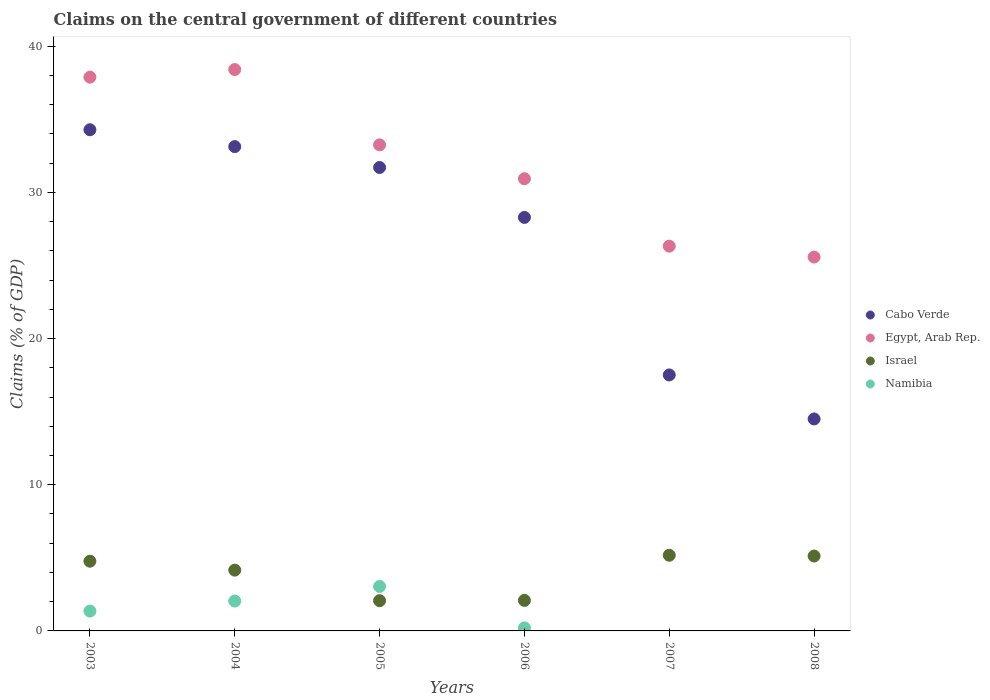Is the number of dotlines equal to the number of legend labels?
Give a very brief answer. No. What is the percentage of GDP claimed on the central government in Israel in 2005?
Ensure brevity in your answer.  2.07. Across all years, what is the maximum percentage of GDP claimed on the central government in Israel?
Your response must be concise. 5.18. What is the total percentage of GDP claimed on the central government in Namibia in the graph?
Ensure brevity in your answer.  6.65. What is the difference between the percentage of GDP claimed on the central government in Cabo Verde in 2006 and that in 2007?
Your response must be concise. 10.77. What is the difference between the percentage of GDP claimed on the central government in Egypt, Arab Rep. in 2006 and the percentage of GDP claimed on the central government in Namibia in 2003?
Offer a terse response. 29.57. What is the average percentage of GDP claimed on the central government in Egypt, Arab Rep. per year?
Provide a short and direct response. 32.06. In the year 2004, what is the difference between the percentage of GDP claimed on the central government in Cabo Verde and percentage of GDP claimed on the central government in Egypt, Arab Rep.?
Your answer should be very brief. -5.27. In how many years, is the percentage of GDP claimed on the central government in Namibia greater than 36 %?
Your answer should be compact. 0. What is the ratio of the percentage of GDP claimed on the central government in Namibia in 2005 to that in 2006?
Your answer should be compact. 14.51. Is the percentage of GDP claimed on the central government in Israel in 2005 less than that in 2006?
Provide a succinct answer. Yes. What is the difference between the highest and the second highest percentage of GDP claimed on the central government in Namibia?
Make the answer very short. 1. What is the difference between the highest and the lowest percentage of GDP claimed on the central government in Namibia?
Keep it short and to the point. 3.04. Is the sum of the percentage of GDP claimed on the central government in Egypt, Arab Rep. in 2003 and 2004 greater than the maximum percentage of GDP claimed on the central government in Namibia across all years?
Your answer should be very brief. Yes. Is the percentage of GDP claimed on the central government in Cabo Verde strictly greater than the percentage of GDP claimed on the central government in Namibia over the years?
Provide a short and direct response. Yes. Is the percentage of GDP claimed on the central government in Israel strictly less than the percentage of GDP claimed on the central government in Cabo Verde over the years?
Your answer should be compact. Yes. How many dotlines are there?
Offer a very short reply. 4. How many years are there in the graph?
Your answer should be compact. 6. Are the values on the major ticks of Y-axis written in scientific E-notation?
Ensure brevity in your answer.  No. Does the graph contain any zero values?
Give a very brief answer. Yes. How many legend labels are there?
Ensure brevity in your answer.  4. What is the title of the graph?
Your answer should be very brief. Claims on the central government of different countries. What is the label or title of the Y-axis?
Make the answer very short. Claims (% of GDP). What is the Claims (% of GDP) of Cabo Verde in 2003?
Provide a succinct answer. 34.28. What is the Claims (% of GDP) of Egypt, Arab Rep. in 2003?
Your answer should be very brief. 37.88. What is the Claims (% of GDP) of Israel in 2003?
Your answer should be compact. 4.77. What is the Claims (% of GDP) of Namibia in 2003?
Provide a succinct answer. 1.36. What is the Claims (% of GDP) in Cabo Verde in 2004?
Your answer should be compact. 33.13. What is the Claims (% of GDP) in Egypt, Arab Rep. in 2004?
Ensure brevity in your answer.  38.4. What is the Claims (% of GDP) in Israel in 2004?
Make the answer very short. 4.16. What is the Claims (% of GDP) of Namibia in 2004?
Give a very brief answer. 2.04. What is the Claims (% of GDP) of Cabo Verde in 2005?
Give a very brief answer. 31.7. What is the Claims (% of GDP) of Egypt, Arab Rep. in 2005?
Offer a very short reply. 33.25. What is the Claims (% of GDP) of Israel in 2005?
Provide a succinct answer. 2.07. What is the Claims (% of GDP) in Namibia in 2005?
Keep it short and to the point. 3.04. What is the Claims (% of GDP) of Cabo Verde in 2006?
Provide a succinct answer. 28.29. What is the Claims (% of GDP) in Egypt, Arab Rep. in 2006?
Provide a short and direct response. 30.93. What is the Claims (% of GDP) in Israel in 2006?
Ensure brevity in your answer.  2.09. What is the Claims (% of GDP) of Namibia in 2006?
Your response must be concise. 0.21. What is the Claims (% of GDP) in Cabo Verde in 2007?
Offer a terse response. 17.51. What is the Claims (% of GDP) in Egypt, Arab Rep. in 2007?
Your response must be concise. 26.32. What is the Claims (% of GDP) in Israel in 2007?
Ensure brevity in your answer.  5.18. What is the Claims (% of GDP) in Namibia in 2007?
Give a very brief answer. 0. What is the Claims (% of GDP) in Cabo Verde in 2008?
Your response must be concise. 14.5. What is the Claims (% of GDP) in Egypt, Arab Rep. in 2008?
Make the answer very short. 25.57. What is the Claims (% of GDP) of Israel in 2008?
Provide a short and direct response. 5.12. What is the Claims (% of GDP) of Namibia in 2008?
Provide a succinct answer. 0. Across all years, what is the maximum Claims (% of GDP) of Cabo Verde?
Your answer should be very brief. 34.28. Across all years, what is the maximum Claims (% of GDP) in Egypt, Arab Rep.?
Keep it short and to the point. 38.4. Across all years, what is the maximum Claims (% of GDP) of Israel?
Keep it short and to the point. 5.18. Across all years, what is the maximum Claims (% of GDP) of Namibia?
Provide a succinct answer. 3.04. Across all years, what is the minimum Claims (% of GDP) of Cabo Verde?
Offer a terse response. 14.5. Across all years, what is the minimum Claims (% of GDP) in Egypt, Arab Rep.?
Offer a terse response. 25.57. Across all years, what is the minimum Claims (% of GDP) of Israel?
Provide a succinct answer. 2.07. Across all years, what is the minimum Claims (% of GDP) of Namibia?
Keep it short and to the point. 0. What is the total Claims (% of GDP) of Cabo Verde in the graph?
Make the answer very short. 159.4. What is the total Claims (% of GDP) of Egypt, Arab Rep. in the graph?
Your response must be concise. 192.35. What is the total Claims (% of GDP) of Israel in the graph?
Give a very brief answer. 23.38. What is the total Claims (% of GDP) of Namibia in the graph?
Your answer should be very brief. 6.65. What is the difference between the Claims (% of GDP) of Cabo Verde in 2003 and that in 2004?
Offer a very short reply. 1.15. What is the difference between the Claims (% of GDP) in Egypt, Arab Rep. in 2003 and that in 2004?
Give a very brief answer. -0.52. What is the difference between the Claims (% of GDP) in Israel in 2003 and that in 2004?
Provide a short and direct response. 0.61. What is the difference between the Claims (% of GDP) of Namibia in 2003 and that in 2004?
Make the answer very short. -0.68. What is the difference between the Claims (% of GDP) in Cabo Verde in 2003 and that in 2005?
Your response must be concise. 2.58. What is the difference between the Claims (% of GDP) in Egypt, Arab Rep. in 2003 and that in 2005?
Offer a very short reply. 4.63. What is the difference between the Claims (% of GDP) of Israel in 2003 and that in 2005?
Your answer should be very brief. 2.7. What is the difference between the Claims (% of GDP) of Namibia in 2003 and that in 2005?
Give a very brief answer. -1.69. What is the difference between the Claims (% of GDP) in Cabo Verde in 2003 and that in 2006?
Ensure brevity in your answer.  6. What is the difference between the Claims (% of GDP) of Egypt, Arab Rep. in 2003 and that in 2006?
Your answer should be very brief. 6.95. What is the difference between the Claims (% of GDP) of Israel in 2003 and that in 2006?
Give a very brief answer. 2.68. What is the difference between the Claims (% of GDP) in Namibia in 2003 and that in 2006?
Your answer should be compact. 1.15. What is the difference between the Claims (% of GDP) in Cabo Verde in 2003 and that in 2007?
Your answer should be compact. 16.77. What is the difference between the Claims (% of GDP) of Egypt, Arab Rep. in 2003 and that in 2007?
Provide a short and direct response. 11.56. What is the difference between the Claims (% of GDP) of Israel in 2003 and that in 2007?
Your answer should be compact. -0.41. What is the difference between the Claims (% of GDP) of Cabo Verde in 2003 and that in 2008?
Your response must be concise. 19.78. What is the difference between the Claims (% of GDP) in Egypt, Arab Rep. in 2003 and that in 2008?
Provide a short and direct response. 12.31. What is the difference between the Claims (% of GDP) in Israel in 2003 and that in 2008?
Make the answer very short. -0.35. What is the difference between the Claims (% of GDP) of Cabo Verde in 2004 and that in 2005?
Make the answer very short. 1.43. What is the difference between the Claims (% of GDP) of Egypt, Arab Rep. in 2004 and that in 2005?
Your answer should be compact. 5.15. What is the difference between the Claims (% of GDP) of Israel in 2004 and that in 2005?
Provide a short and direct response. 2.09. What is the difference between the Claims (% of GDP) of Namibia in 2004 and that in 2005?
Make the answer very short. -1. What is the difference between the Claims (% of GDP) of Cabo Verde in 2004 and that in 2006?
Make the answer very short. 4.84. What is the difference between the Claims (% of GDP) of Egypt, Arab Rep. in 2004 and that in 2006?
Your answer should be compact. 7.47. What is the difference between the Claims (% of GDP) of Israel in 2004 and that in 2006?
Keep it short and to the point. 2.07. What is the difference between the Claims (% of GDP) of Namibia in 2004 and that in 2006?
Offer a terse response. 1.83. What is the difference between the Claims (% of GDP) in Cabo Verde in 2004 and that in 2007?
Offer a terse response. 15.62. What is the difference between the Claims (% of GDP) of Egypt, Arab Rep. in 2004 and that in 2007?
Your answer should be very brief. 12.08. What is the difference between the Claims (% of GDP) in Israel in 2004 and that in 2007?
Offer a very short reply. -1.02. What is the difference between the Claims (% of GDP) of Cabo Verde in 2004 and that in 2008?
Keep it short and to the point. 18.63. What is the difference between the Claims (% of GDP) of Egypt, Arab Rep. in 2004 and that in 2008?
Your answer should be compact. 12.83. What is the difference between the Claims (% of GDP) in Israel in 2004 and that in 2008?
Your answer should be compact. -0.96. What is the difference between the Claims (% of GDP) in Cabo Verde in 2005 and that in 2006?
Offer a terse response. 3.42. What is the difference between the Claims (% of GDP) of Egypt, Arab Rep. in 2005 and that in 2006?
Provide a short and direct response. 2.32. What is the difference between the Claims (% of GDP) in Israel in 2005 and that in 2006?
Offer a very short reply. -0.02. What is the difference between the Claims (% of GDP) in Namibia in 2005 and that in 2006?
Make the answer very short. 2.83. What is the difference between the Claims (% of GDP) of Cabo Verde in 2005 and that in 2007?
Offer a terse response. 14.19. What is the difference between the Claims (% of GDP) in Egypt, Arab Rep. in 2005 and that in 2007?
Offer a very short reply. 6.93. What is the difference between the Claims (% of GDP) in Israel in 2005 and that in 2007?
Offer a very short reply. -3.11. What is the difference between the Claims (% of GDP) in Cabo Verde in 2005 and that in 2008?
Your response must be concise. 17.2. What is the difference between the Claims (% of GDP) of Egypt, Arab Rep. in 2005 and that in 2008?
Provide a succinct answer. 7.67. What is the difference between the Claims (% of GDP) in Israel in 2005 and that in 2008?
Your response must be concise. -3.05. What is the difference between the Claims (% of GDP) in Cabo Verde in 2006 and that in 2007?
Offer a terse response. 10.77. What is the difference between the Claims (% of GDP) in Egypt, Arab Rep. in 2006 and that in 2007?
Give a very brief answer. 4.61. What is the difference between the Claims (% of GDP) in Israel in 2006 and that in 2007?
Make the answer very short. -3.09. What is the difference between the Claims (% of GDP) of Cabo Verde in 2006 and that in 2008?
Your answer should be compact. 13.79. What is the difference between the Claims (% of GDP) in Egypt, Arab Rep. in 2006 and that in 2008?
Ensure brevity in your answer.  5.36. What is the difference between the Claims (% of GDP) of Israel in 2006 and that in 2008?
Provide a succinct answer. -3.03. What is the difference between the Claims (% of GDP) of Cabo Verde in 2007 and that in 2008?
Your answer should be compact. 3.01. What is the difference between the Claims (% of GDP) in Egypt, Arab Rep. in 2007 and that in 2008?
Provide a succinct answer. 0.75. What is the difference between the Claims (% of GDP) of Israel in 2007 and that in 2008?
Give a very brief answer. 0.05. What is the difference between the Claims (% of GDP) in Cabo Verde in 2003 and the Claims (% of GDP) in Egypt, Arab Rep. in 2004?
Offer a terse response. -4.12. What is the difference between the Claims (% of GDP) of Cabo Verde in 2003 and the Claims (% of GDP) of Israel in 2004?
Give a very brief answer. 30.12. What is the difference between the Claims (% of GDP) in Cabo Verde in 2003 and the Claims (% of GDP) in Namibia in 2004?
Keep it short and to the point. 32.24. What is the difference between the Claims (% of GDP) in Egypt, Arab Rep. in 2003 and the Claims (% of GDP) in Israel in 2004?
Ensure brevity in your answer.  33.72. What is the difference between the Claims (% of GDP) of Egypt, Arab Rep. in 2003 and the Claims (% of GDP) of Namibia in 2004?
Your answer should be very brief. 35.84. What is the difference between the Claims (% of GDP) of Israel in 2003 and the Claims (% of GDP) of Namibia in 2004?
Provide a short and direct response. 2.73. What is the difference between the Claims (% of GDP) in Cabo Verde in 2003 and the Claims (% of GDP) in Egypt, Arab Rep. in 2005?
Provide a short and direct response. 1.03. What is the difference between the Claims (% of GDP) of Cabo Verde in 2003 and the Claims (% of GDP) of Israel in 2005?
Ensure brevity in your answer.  32.21. What is the difference between the Claims (% of GDP) of Cabo Verde in 2003 and the Claims (% of GDP) of Namibia in 2005?
Your answer should be very brief. 31.24. What is the difference between the Claims (% of GDP) in Egypt, Arab Rep. in 2003 and the Claims (% of GDP) in Israel in 2005?
Your response must be concise. 35.81. What is the difference between the Claims (% of GDP) in Egypt, Arab Rep. in 2003 and the Claims (% of GDP) in Namibia in 2005?
Ensure brevity in your answer.  34.83. What is the difference between the Claims (% of GDP) in Israel in 2003 and the Claims (% of GDP) in Namibia in 2005?
Your answer should be compact. 1.73. What is the difference between the Claims (% of GDP) of Cabo Verde in 2003 and the Claims (% of GDP) of Egypt, Arab Rep. in 2006?
Your answer should be very brief. 3.35. What is the difference between the Claims (% of GDP) in Cabo Verde in 2003 and the Claims (% of GDP) in Israel in 2006?
Your answer should be compact. 32.19. What is the difference between the Claims (% of GDP) in Cabo Verde in 2003 and the Claims (% of GDP) in Namibia in 2006?
Make the answer very short. 34.07. What is the difference between the Claims (% of GDP) in Egypt, Arab Rep. in 2003 and the Claims (% of GDP) in Israel in 2006?
Your response must be concise. 35.79. What is the difference between the Claims (% of GDP) in Egypt, Arab Rep. in 2003 and the Claims (% of GDP) in Namibia in 2006?
Your answer should be compact. 37.67. What is the difference between the Claims (% of GDP) in Israel in 2003 and the Claims (% of GDP) in Namibia in 2006?
Keep it short and to the point. 4.56. What is the difference between the Claims (% of GDP) of Cabo Verde in 2003 and the Claims (% of GDP) of Egypt, Arab Rep. in 2007?
Keep it short and to the point. 7.96. What is the difference between the Claims (% of GDP) of Cabo Verde in 2003 and the Claims (% of GDP) of Israel in 2007?
Provide a short and direct response. 29.11. What is the difference between the Claims (% of GDP) of Egypt, Arab Rep. in 2003 and the Claims (% of GDP) of Israel in 2007?
Your answer should be compact. 32.7. What is the difference between the Claims (% of GDP) in Cabo Verde in 2003 and the Claims (% of GDP) in Egypt, Arab Rep. in 2008?
Give a very brief answer. 8.71. What is the difference between the Claims (% of GDP) in Cabo Verde in 2003 and the Claims (% of GDP) in Israel in 2008?
Ensure brevity in your answer.  29.16. What is the difference between the Claims (% of GDP) in Egypt, Arab Rep. in 2003 and the Claims (% of GDP) in Israel in 2008?
Ensure brevity in your answer.  32.76. What is the difference between the Claims (% of GDP) of Cabo Verde in 2004 and the Claims (% of GDP) of Egypt, Arab Rep. in 2005?
Your answer should be compact. -0.12. What is the difference between the Claims (% of GDP) of Cabo Verde in 2004 and the Claims (% of GDP) of Israel in 2005?
Give a very brief answer. 31.06. What is the difference between the Claims (% of GDP) in Cabo Verde in 2004 and the Claims (% of GDP) in Namibia in 2005?
Provide a succinct answer. 30.08. What is the difference between the Claims (% of GDP) of Egypt, Arab Rep. in 2004 and the Claims (% of GDP) of Israel in 2005?
Provide a succinct answer. 36.33. What is the difference between the Claims (% of GDP) of Egypt, Arab Rep. in 2004 and the Claims (% of GDP) of Namibia in 2005?
Your response must be concise. 35.36. What is the difference between the Claims (% of GDP) of Israel in 2004 and the Claims (% of GDP) of Namibia in 2005?
Ensure brevity in your answer.  1.11. What is the difference between the Claims (% of GDP) of Cabo Verde in 2004 and the Claims (% of GDP) of Egypt, Arab Rep. in 2006?
Make the answer very short. 2.2. What is the difference between the Claims (% of GDP) in Cabo Verde in 2004 and the Claims (% of GDP) in Israel in 2006?
Offer a terse response. 31.04. What is the difference between the Claims (% of GDP) of Cabo Verde in 2004 and the Claims (% of GDP) of Namibia in 2006?
Your answer should be very brief. 32.92. What is the difference between the Claims (% of GDP) in Egypt, Arab Rep. in 2004 and the Claims (% of GDP) in Israel in 2006?
Provide a succinct answer. 36.31. What is the difference between the Claims (% of GDP) of Egypt, Arab Rep. in 2004 and the Claims (% of GDP) of Namibia in 2006?
Give a very brief answer. 38.19. What is the difference between the Claims (% of GDP) of Israel in 2004 and the Claims (% of GDP) of Namibia in 2006?
Provide a short and direct response. 3.95. What is the difference between the Claims (% of GDP) of Cabo Verde in 2004 and the Claims (% of GDP) of Egypt, Arab Rep. in 2007?
Offer a terse response. 6.81. What is the difference between the Claims (% of GDP) in Cabo Verde in 2004 and the Claims (% of GDP) in Israel in 2007?
Keep it short and to the point. 27.95. What is the difference between the Claims (% of GDP) of Egypt, Arab Rep. in 2004 and the Claims (% of GDP) of Israel in 2007?
Offer a terse response. 33.22. What is the difference between the Claims (% of GDP) of Cabo Verde in 2004 and the Claims (% of GDP) of Egypt, Arab Rep. in 2008?
Offer a terse response. 7.55. What is the difference between the Claims (% of GDP) of Cabo Verde in 2004 and the Claims (% of GDP) of Israel in 2008?
Provide a short and direct response. 28. What is the difference between the Claims (% of GDP) of Egypt, Arab Rep. in 2004 and the Claims (% of GDP) of Israel in 2008?
Your answer should be compact. 33.28. What is the difference between the Claims (% of GDP) of Cabo Verde in 2005 and the Claims (% of GDP) of Egypt, Arab Rep. in 2006?
Your response must be concise. 0.77. What is the difference between the Claims (% of GDP) in Cabo Verde in 2005 and the Claims (% of GDP) in Israel in 2006?
Keep it short and to the point. 29.61. What is the difference between the Claims (% of GDP) in Cabo Verde in 2005 and the Claims (% of GDP) in Namibia in 2006?
Your answer should be compact. 31.49. What is the difference between the Claims (% of GDP) in Egypt, Arab Rep. in 2005 and the Claims (% of GDP) in Israel in 2006?
Offer a terse response. 31.16. What is the difference between the Claims (% of GDP) in Egypt, Arab Rep. in 2005 and the Claims (% of GDP) in Namibia in 2006?
Ensure brevity in your answer.  33.04. What is the difference between the Claims (% of GDP) of Israel in 2005 and the Claims (% of GDP) of Namibia in 2006?
Give a very brief answer. 1.86. What is the difference between the Claims (% of GDP) in Cabo Verde in 2005 and the Claims (% of GDP) in Egypt, Arab Rep. in 2007?
Ensure brevity in your answer.  5.38. What is the difference between the Claims (% of GDP) of Cabo Verde in 2005 and the Claims (% of GDP) of Israel in 2007?
Keep it short and to the point. 26.52. What is the difference between the Claims (% of GDP) in Egypt, Arab Rep. in 2005 and the Claims (% of GDP) in Israel in 2007?
Keep it short and to the point. 28.07. What is the difference between the Claims (% of GDP) of Cabo Verde in 2005 and the Claims (% of GDP) of Egypt, Arab Rep. in 2008?
Offer a very short reply. 6.13. What is the difference between the Claims (% of GDP) in Cabo Verde in 2005 and the Claims (% of GDP) in Israel in 2008?
Keep it short and to the point. 26.58. What is the difference between the Claims (% of GDP) of Egypt, Arab Rep. in 2005 and the Claims (% of GDP) of Israel in 2008?
Your answer should be very brief. 28.12. What is the difference between the Claims (% of GDP) in Cabo Verde in 2006 and the Claims (% of GDP) in Egypt, Arab Rep. in 2007?
Offer a very short reply. 1.97. What is the difference between the Claims (% of GDP) in Cabo Verde in 2006 and the Claims (% of GDP) in Israel in 2007?
Provide a short and direct response. 23.11. What is the difference between the Claims (% of GDP) in Egypt, Arab Rep. in 2006 and the Claims (% of GDP) in Israel in 2007?
Offer a very short reply. 25.75. What is the difference between the Claims (% of GDP) in Cabo Verde in 2006 and the Claims (% of GDP) in Egypt, Arab Rep. in 2008?
Your answer should be very brief. 2.71. What is the difference between the Claims (% of GDP) of Cabo Verde in 2006 and the Claims (% of GDP) of Israel in 2008?
Ensure brevity in your answer.  23.16. What is the difference between the Claims (% of GDP) in Egypt, Arab Rep. in 2006 and the Claims (% of GDP) in Israel in 2008?
Provide a succinct answer. 25.81. What is the difference between the Claims (% of GDP) of Cabo Verde in 2007 and the Claims (% of GDP) of Egypt, Arab Rep. in 2008?
Keep it short and to the point. -8.06. What is the difference between the Claims (% of GDP) in Cabo Verde in 2007 and the Claims (% of GDP) in Israel in 2008?
Ensure brevity in your answer.  12.39. What is the difference between the Claims (% of GDP) in Egypt, Arab Rep. in 2007 and the Claims (% of GDP) in Israel in 2008?
Your answer should be very brief. 21.2. What is the average Claims (% of GDP) of Cabo Verde per year?
Your answer should be very brief. 26.57. What is the average Claims (% of GDP) of Egypt, Arab Rep. per year?
Give a very brief answer. 32.06. What is the average Claims (% of GDP) of Israel per year?
Keep it short and to the point. 3.9. What is the average Claims (% of GDP) in Namibia per year?
Your answer should be very brief. 1.11. In the year 2003, what is the difference between the Claims (% of GDP) of Cabo Verde and Claims (% of GDP) of Egypt, Arab Rep.?
Offer a terse response. -3.6. In the year 2003, what is the difference between the Claims (% of GDP) of Cabo Verde and Claims (% of GDP) of Israel?
Your response must be concise. 29.51. In the year 2003, what is the difference between the Claims (% of GDP) of Cabo Verde and Claims (% of GDP) of Namibia?
Your response must be concise. 32.92. In the year 2003, what is the difference between the Claims (% of GDP) in Egypt, Arab Rep. and Claims (% of GDP) in Israel?
Offer a very short reply. 33.11. In the year 2003, what is the difference between the Claims (% of GDP) in Egypt, Arab Rep. and Claims (% of GDP) in Namibia?
Your response must be concise. 36.52. In the year 2003, what is the difference between the Claims (% of GDP) in Israel and Claims (% of GDP) in Namibia?
Give a very brief answer. 3.41. In the year 2004, what is the difference between the Claims (% of GDP) in Cabo Verde and Claims (% of GDP) in Egypt, Arab Rep.?
Give a very brief answer. -5.27. In the year 2004, what is the difference between the Claims (% of GDP) in Cabo Verde and Claims (% of GDP) in Israel?
Provide a succinct answer. 28.97. In the year 2004, what is the difference between the Claims (% of GDP) in Cabo Verde and Claims (% of GDP) in Namibia?
Provide a short and direct response. 31.08. In the year 2004, what is the difference between the Claims (% of GDP) in Egypt, Arab Rep. and Claims (% of GDP) in Israel?
Offer a very short reply. 34.24. In the year 2004, what is the difference between the Claims (% of GDP) of Egypt, Arab Rep. and Claims (% of GDP) of Namibia?
Keep it short and to the point. 36.36. In the year 2004, what is the difference between the Claims (% of GDP) of Israel and Claims (% of GDP) of Namibia?
Give a very brief answer. 2.12. In the year 2005, what is the difference between the Claims (% of GDP) of Cabo Verde and Claims (% of GDP) of Egypt, Arab Rep.?
Make the answer very short. -1.55. In the year 2005, what is the difference between the Claims (% of GDP) in Cabo Verde and Claims (% of GDP) in Israel?
Your response must be concise. 29.63. In the year 2005, what is the difference between the Claims (% of GDP) in Cabo Verde and Claims (% of GDP) in Namibia?
Your answer should be compact. 28.66. In the year 2005, what is the difference between the Claims (% of GDP) in Egypt, Arab Rep. and Claims (% of GDP) in Israel?
Offer a very short reply. 31.18. In the year 2005, what is the difference between the Claims (% of GDP) in Egypt, Arab Rep. and Claims (% of GDP) in Namibia?
Provide a short and direct response. 30.2. In the year 2005, what is the difference between the Claims (% of GDP) in Israel and Claims (% of GDP) in Namibia?
Make the answer very short. -0.98. In the year 2006, what is the difference between the Claims (% of GDP) in Cabo Verde and Claims (% of GDP) in Egypt, Arab Rep.?
Your answer should be compact. -2.65. In the year 2006, what is the difference between the Claims (% of GDP) of Cabo Verde and Claims (% of GDP) of Israel?
Ensure brevity in your answer.  26.2. In the year 2006, what is the difference between the Claims (% of GDP) in Cabo Verde and Claims (% of GDP) in Namibia?
Offer a very short reply. 28.08. In the year 2006, what is the difference between the Claims (% of GDP) in Egypt, Arab Rep. and Claims (% of GDP) in Israel?
Your answer should be very brief. 28.84. In the year 2006, what is the difference between the Claims (% of GDP) of Egypt, Arab Rep. and Claims (% of GDP) of Namibia?
Give a very brief answer. 30.72. In the year 2006, what is the difference between the Claims (% of GDP) of Israel and Claims (% of GDP) of Namibia?
Offer a very short reply. 1.88. In the year 2007, what is the difference between the Claims (% of GDP) in Cabo Verde and Claims (% of GDP) in Egypt, Arab Rep.?
Offer a terse response. -8.81. In the year 2007, what is the difference between the Claims (% of GDP) in Cabo Verde and Claims (% of GDP) in Israel?
Provide a short and direct response. 12.33. In the year 2007, what is the difference between the Claims (% of GDP) in Egypt, Arab Rep. and Claims (% of GDP) in Israel?
Provide a short and direct response. 21.14. In the year 2008, what is the difference between the Claims (% of GDP) in Cabo Verde and Claims (% of GDP) in Egypt, Arab Rep.?
Give a very brief answer. -11.07. In the year 2008, what is the difference between the Claims (% of GDP) of Cabo Verde and Claims (% of GDP) of Israel?
Your answer should be compact. 9.38. In the year 2008, what is the difference between the Claims (% of GDP) of Egypt, Arab Rep. and Claims (% of GDP) of Israel?
Your answer should be very brief. 20.45. What is the ratio of the Claims (% of GDP) in Cabo Verde in 2003 to that in 2004?
Your answer should be very brief. 1.03. What is the ratio of the Claims (% of GDP) in Egypt, Arab Rep. in 2003 to that in 2004?
Your answer should be very brief. 0.99. What is the ratio of the Claims (% of GDP) of Israel in 2003 to that in 2004?
Offer a very short reply. 1.15. What is the ratio of the Claims (% of GDP) in Namibia in 2003 to that in 2004?
Offer a very short reply. 0.67. What is the ratio of the Claims (% of GDP) in Cabo Verde in 2003 to that in 2005?
Make the answer very short. 1.08. What is the ratio of the Claims (% of GDP) of Egypt, Arab Rep. in 2003 to that in 2005?
Your answer should be very brief. 1.14. What is the ratio of the Claims (% of GDP) in Israel in 2003 to that in 2005?
Provide a short and direct response. 2.31. What is the ratio of the Claims (% of GDP) of Namibia in 2003 to that in 2005?
Offer a terse response. 0.45. What is the ratio of the Claims (% of GDP) in Cabo Verde in 2003 to that in 2006?
Your answer should be compact. 1.21. What is the ratio of the Claims (% of GDP) of Egypt, Arab Rep. in 2003 to that in 2006?
Offer a very short reply. 1.22. What is the ratio of the Claims (% of GDP) in Israel in 2003 to that in 2006?
Offer a very short reply. 2.28. What is the ratio of the Claims (% of GDP) of Namibia in 2003 to that in 2006?
Offer a terse response. 6.48. What is the ratio of the Claims (% of GDP) in Cabo Verde in 2003 to that in 2007?
Give a very brief answer. 1.96. What is the ratio of the Claims (% of GDP) in Egypt, Arab Rep. in 2003 to that in 2007?
Your answer should be compact. 1.44. What is the ratio of the Claims (% of GDP) of Israel in 2003 to that in 2007?
Offer a terse response. 0.92. What is the ratio of the Claims (% of GDP) in Cabo Verde in 2003 to that in 2008?
Provide a short and direct response. 2.36. What is the ratio of the Claims (% of GDP) in Egypt, Arab Rep. in 2003 to that in 2008?
Your answer should be very brief. 1.48. What is the ratio of the Claims (% of GDP) of Israel in 2003 to that in 2008?
Your answer should be compact. 0.93. What is the ratio of the Claims (% of GDP) of Cabo Verde in 2004 to that in 2005?
Give a very brief answer. 1.04. What is the ratio of the Claims (% of GDP) of Egypt, Arab Rep. in 2004 to that in 2005?
Provide a short and direct response. 1.16. What is the ratio of the Claims (% of GDP) of Israel in 2004 to that in 2005?
Ensure brevity in your answer.  2.01. What is the ratio of the Claims (% of GDP) of Namibia in 2004 to that in 2005?
Your answer should be compact. 0.67. What is the ratio of the Claims (% of GDP) of Cabo Verde in 2004 to that in 2006?
Your response must be concise. 1.17. What is the ratio of the Claims (% of GDP) of Egypt, Arab Rep. in 2004 to that in 2006?
Offer a terse response. 1.24. What is the ratio of the Claims (% of GDP) of Israel in 2004 to that in 2006?
Give a very brief answer. 1.99. What is the ratio of the Claims (% of GDP) of Namibia in 2004 to that in 2006?
Your response must be concise. 9.74. What is the ratio of the Claims (% of GDP) of Cabo Verde in 2004 to that in 2007?
Make the answer very short. 1.89. What is the ratio of the Claims (% of GDP) in Egypt, Arab Rep. in 2004 to that in 2007?
Offer a terse response. 1.46. What is the ratio of the Claims (% of GDP) of Israel in 2004 to that in 2007?
Your response must be concise. 0.8. What is the ratio of the Claims (% of GDP) of Cabo Verde in 2004 to that in 2008?
Your answer should be compact. 2.28. What is the ratio of the Claims (% of GDP) in Egypt, Arab Rep. in 2004 to that in 2008?
Offer a terse response. 1.5. What is the ratio of the Claims (% of GDP) of Israel in 2004 to that in 2008?
Give a very brief answer. 0.81. What is the ratio of the Claims (% of GDP) in Cabo Verde in 2005 to that in 2006?
Your response must be concise. 1.12. What is the ratio of the Claims (% of GDP) of Egypt, Arab Rep. in 2005 to that in 2006?
Provide a short and direct response. 1.07. What is the ratio of the Claims (% of GDP) of Israel in 2005 to that in 2006?
Your answer should be very brief. 0.99. What is the ratio of the Claims (% of GDP) in Namibia in 2005 to that in 2006?
Give a very brief answer. 14.51. What is the ratio of the Claims (% of GDP) of Cabo Verde in 2005 to that in 2007?
Provide a succinct answer. 1.81. What is the ratio of the Claims (% of GDP) in Egypt, Arab Rep. in 2005 to that in 2007?
Keep it short and to the point. 1.26. What is the ratio of the Claims (% of GDP) of Israel in 2005 to that in 2007?
Give a very brief answer. 0.4. What is the ratio of the Claims (% of GDP) of Cabo Verde in 2005 to that in 2008?
Your answer should be compact. 2.19. What is the ratio of the Claims (% of GDP) in Egypt, Arab Rep. in 2005 to that in 2008?
Your response must be concise. 1.3. What is the ratio of the Claims (% of GDP) in Israel in 2005 to that in 2008?
Provide a succinct answer. 0.4. What is the ratio of the Claims (% of GDP) in Cabo Verde in 2006 to that in 2007?
Your answer should be compact. 1.62. What is the ratio of the Claims (% of GDP) of Egypt, Arab Rep. in 2006 to that in 2007?
Your answer should be compact. 1.18. What is the ratio of the Claims (% of GDP) of Israel in 2006 to that in 2007?
Your answer should be very brief. 0.4. What is the ratio of the Claims (% of GDP) in Cabo Verde in 2006 to that in 2008?
Make the answer very short. 1.95. What is the ratio of the Claims (% of GDP) of Egypt, Arab Rep. in 2006 to that in 2008?
Provide a succinct answer. 1.21. What is the ratio of the Claims (% of GDP) in Israel in 2006 to that in 2008?
Ensure brevity in your answer.  0.41. What is the ratio of the Claims (% of GDP) of Cabo Verde in 2007 to that in 2008?
Keep it short and to the point. 1.21. What is the ratio of the Claims (% of GDP) of Egypt, Arab Rep. in 2007 to that in 2008?
Keep it short and to the point. 1.03. What is the ratio of the Claims (% of GDP) in Israel in 2007 to that in 2008?
Make the answer very short. 1.01. What is the difference between the highest and the second highest Claims (% of GDP) in Cabo Verde?
Provide a succinct answer. 1.15. What is the difference between the highest and the second highest Claims (% of GDP) in Egypt, Arab Rep.?
Provide a succinct answer. 0.52. What is the difference between the highest and the second highest Claims (% of GDP) in Israel?
Make the answer very short. 0.05. What is the difference between the highest and the lowest Claims (% of GDP) in Cabo Verde?
Give a very brief answer. 19.78. What is the difference between the highest and the lowest Claims (% of GDP) in Egypt, Arab Rep.?
Your answer should be compact. 12.83. What is the difference between the highest and the lowest Claims (% of GDP) in Israel?
Provide a short and direct response. 3.11. What is the difference between the highest and the lowest Claims (% of GDP) of Namibia?
Ensure brevity in your answer.  3.04. 